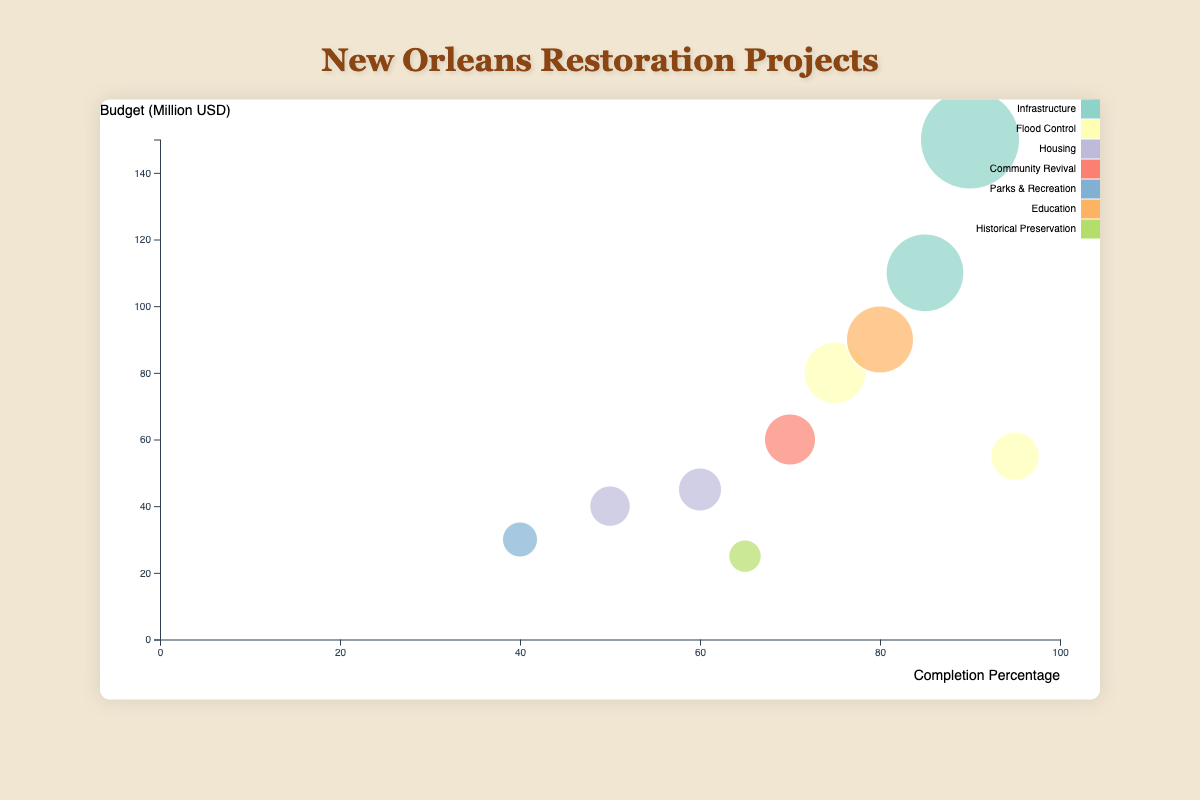What is the budget of the "Lower Ninth Ward Levee Repairs" project? Look for the "Lower Ninth Ward Levee Repairs" project on the bubble chart and note its budget in million USD.
Answer: 150 Which project has the highest completion percentage? Identify the bubble that is farthest to the right on the x-axis (indicating completion percentage) and note the project name.
Answer: French Quarter Drainage Improvement What is the sum of budgets for the "Central City Housing Restoration" and "Uptown Education Facility Rebuilding" projects? Find the two projects on the chart, note their budgets, and add them: 45 + 90 = 135.
Answer: 135 Which area is affected by the largest budgeted project? Identify the bubble with the largest size and note the area affected of that project.
Answer: Lower Ninth Ward How many projects have a completion percentage greater than 75%? Count the number of bubbles positioned to the right of the 75% mark on the x-axis. There are four such projects: Lower Ninth Ward Levee Repairs, East New Orleans Electrical Grid Upgrade, Lakeview Flood Control, French Quarter Drainage Improvement.
Answer: 4 What is the average completion percentage of all "Housing" projects? Find and note the completion percentages of all "Housing" projects: 60 (Central City), 50 (Algiers), then calculate the average: (60 + 50) / 2 = 55.
Answer: 55 Compare the budgets of the "Gentilly Neighborhood Revitalization" and "Mid-City Public Parks Restoration" projects. Which one is greater and by how much? Note the budgets of both projects: 60 (Gentilly) and 30 (Mid-City). Calculate the difference: 60 - 30 = 30. Gentilly has a greater budget by 30.
Answer: Gentilly by 30 Which project is within the "Flood Control" type and has the least completion percentage? Identify all "Flood Control" projects, then find the one with the lowest completion percentage. The projects are: Lakeview Flood Control (75%), French Quarter Drainage Improvement (95%). The lowest is 75%.
Answer: Lakeview Flood Control Based on the size of the bubbles, which project has the smallest budget and what is its budget? Identify the smallest bubble on the chart and note its budget. The smallest is "Bywater Historic Building Conservation" with a budget of 25 million USD.
Answer: Bywater Historic Building Conservation, 25 What is the total budget of all "Infrastructure" projects combined? Add the budgets of all "Infrastructure" projects: 150 (Lower Ninth Ward) + 110 (East New Orleans) = 260.
Answer: 260 